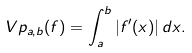Convert formula to latex. <formula><loc_0><loc_0><loc_500><loc_500>\ V p _ { a , b } ( f ) = \int _ { a } ^ { b } | f ^ { \prime } ( x ) | \, d x .</formula> 